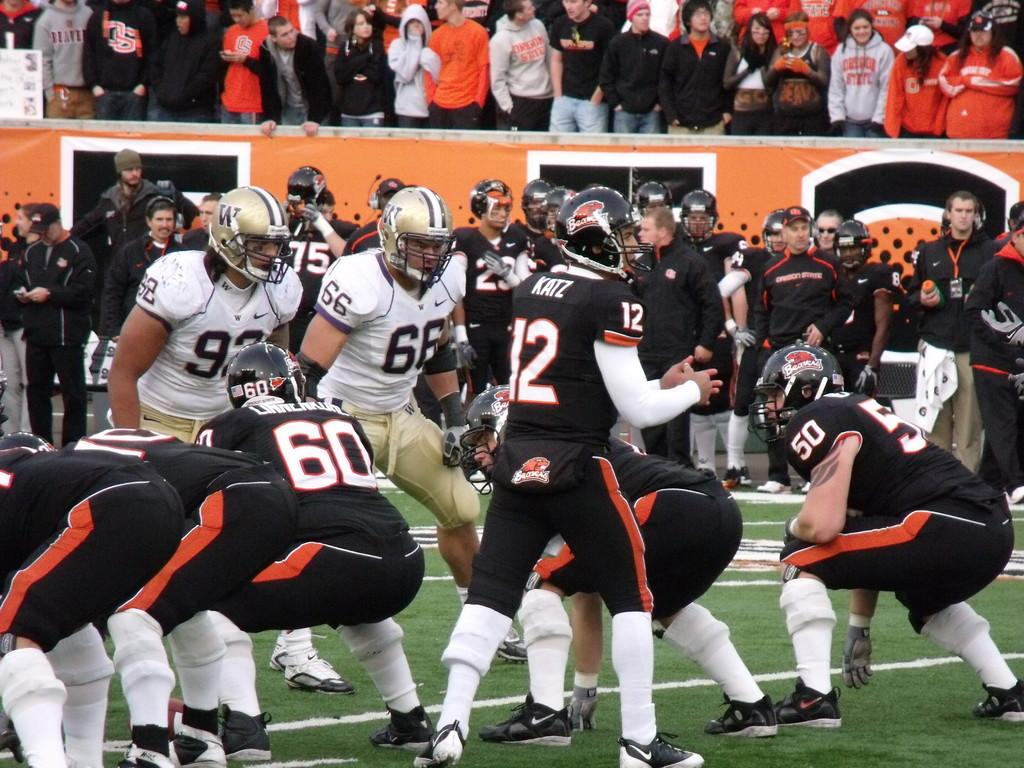What activity are the people engaged in on the ground? The people are playing matches on the ground. Are the matches being played actively? Yes, the matches are being played. Who is observing the matches being played? There are spectators watching the match. On what surface are the matches being played? The matches are being played on the ground. Can you see the self-portrait of the person playing the match in the image? There is no self-portrait present in the image. What request is being made by the spectators in the image? There is no specific request being made by the spectators in the image; they are simply observing the matches being played. 